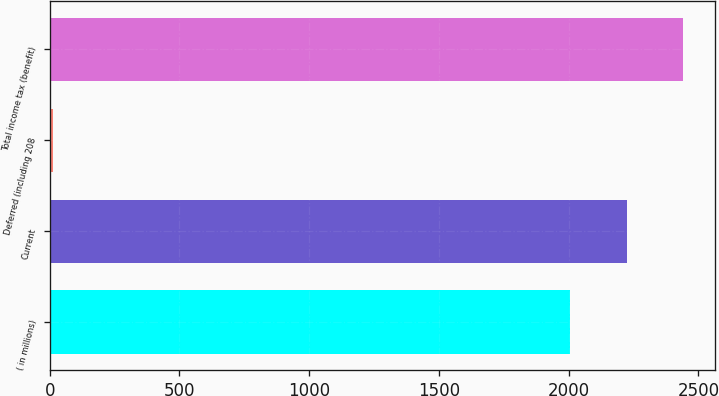Convert chart. <chart><loc_0><loc_0><loc_500><loc_500><bar_chart><fcel>( in millions)<fcel>Current<fcel>Deferred (including 208<fcel>Total income tax (benefit)<nl><fcel>2006<fcel>2223.2<fcel>13<fcel>2440.4<nl></chart> 